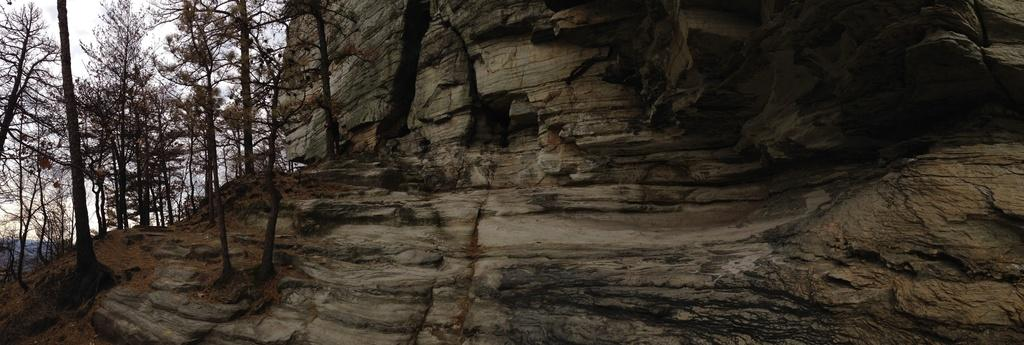What type of landform can be seen in the picture? There is a hill in the picture. What type of vegetation is present in the picture? There are trees in the picture. What part of the natural environment is visible in the picture? The sky is visible in the picture. What type of seed can be seen growing on the hill in the picture? There is no seed visible in the picture; it only shows a hill and trees. 